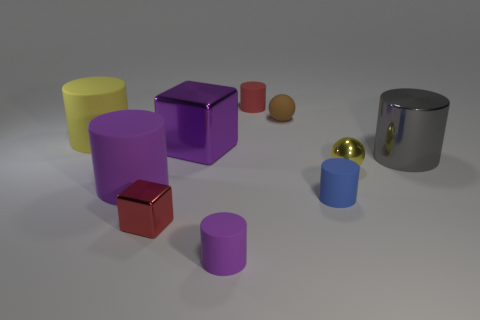Subtract all blue matte cylinders. How many cylinders are left? 5 Subtract all red cylinders. How many cylinders are left? 5 Subtract all brown cylinders. Subtract all gray spheres. How many cylinders are left? 6 Subtract all cylinders. How many objects are left? 4 Add 7 gray metal cylinders. How many gray metal cylinders are left? 8 Add 3 red metallic blocks. How many red metallic blocks exist? 4 Subtract 1 purple cubes. How many objects are left? 9 Subtract all red shiny objects. Subtract all tiny brown things. How many objects are left? 8 